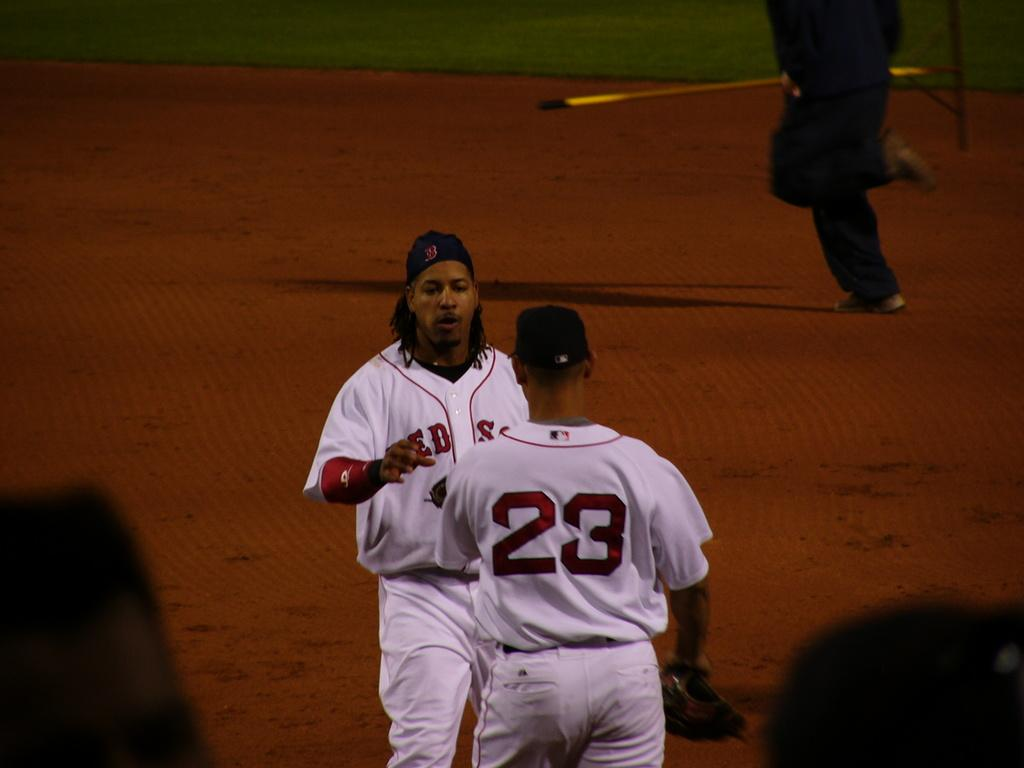<image>
Relay a brief, clear account of the picture shown. Two baseball players are walking toward each other and their jerseys say Red Sox. 